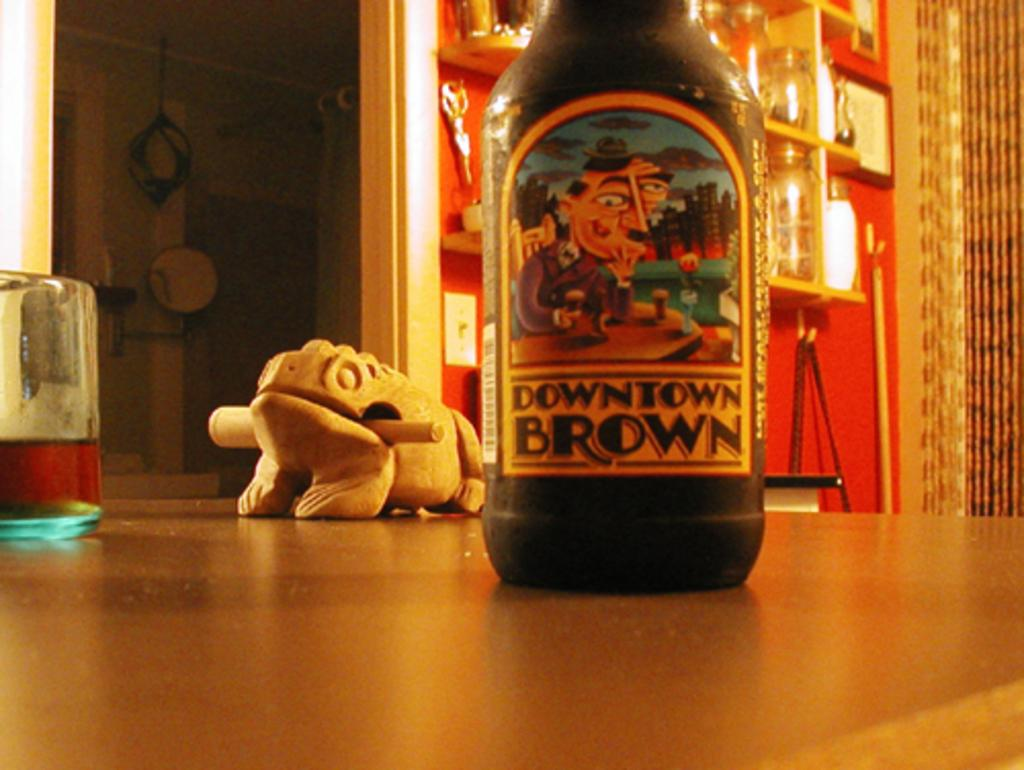Provide a one-sentence caption for the provided image. A bottle of "Downtown Brown" beer sitting on a table top. 